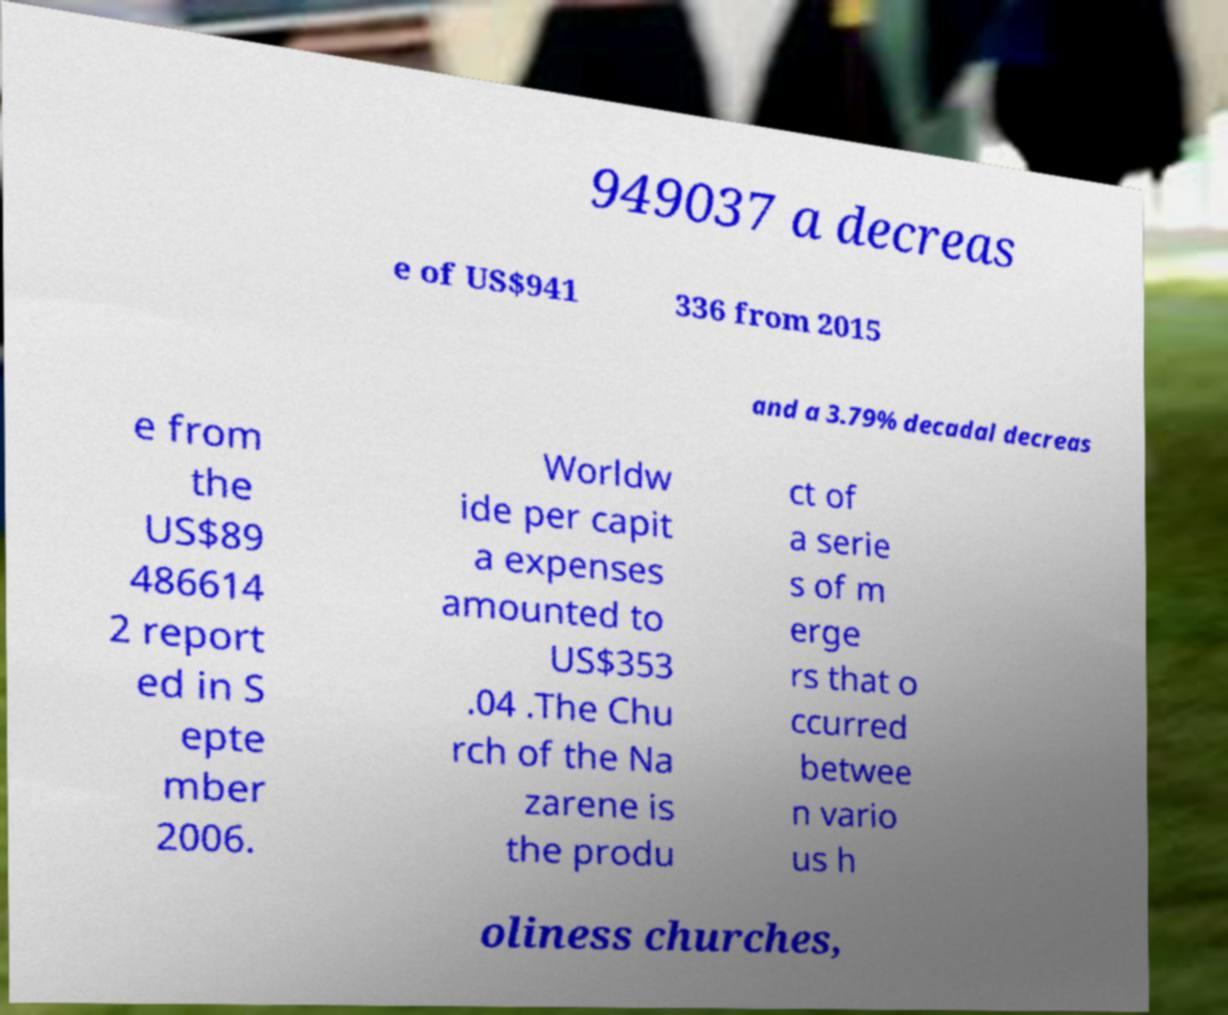Can you accurately transcribe the text from the provided image for me? 949037 a decreas e of US$941 336 from 2015 and a 3.79% decadal decreas e from the US$89 486614 2 report ed in S epte mber 2006. Worldw ide per capit a expenses amounted to US$353 .04 .The Chu rch of the Na zarene is the produ ct of a serie s of m erge rs that o ccurred betwee n vario us h oliness churches, 